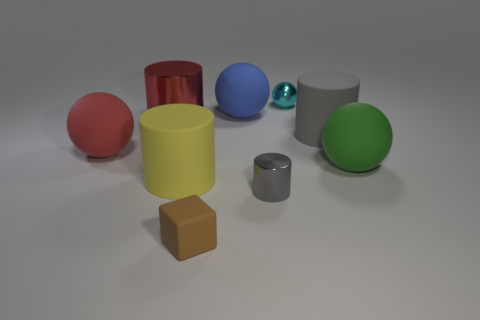There is a cyan thing that is made of the same material as the big red cylinder; what is its shape?
Offer a very short reply. Sphere. Are there more cylinders than tiny brown cylinders?
Give a very brief answer. Yes. Does the tiny gray object have the same shape as the metallic thing that is left of the small rubber block?
Your answer should be compact. Yes. What is the large yellow cylinder made of?
Keep it short and to the point. Rubber. There is a matte sphere that is on the left side of the metal cylinder that is behind the sphere to the left of the tiny brown matte thing; what color is it?
Ensure brevity in your answer.  Red. What is the material of the big gray object that is the same shape as the big red metal object?
Keep it short and to the point. Rubber. How many things are the same size as the cyan metallic ball?
Offer a terse response. 2. What number of green matte things are there?
Provide a succinct answer. 1. Do the big yellow object and the large sphere on the left side of the tiny brown matte object have the same material?
Your answer should be compact. Yes. How many purple objects are small matte blocks or rubber things?
Give a very brief answer. 0. 